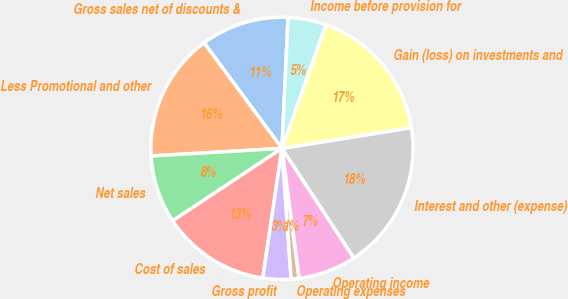Convert chart to OTSL. <chart><loc_0><loc_0><loc_500><loc_500><pie_chart><fcel>Gross sales net of discounts &<fcel>Less Promotional and other<fcel>Net sales<fcel>Cost of sales<fcel>Gross profit<fcel>Operating expenses<fcel>Operating income<fcel>Interest and other (expense)<fcel>Gain (loss) on investments and<fcel>Income before provision for<nl><fcel>10.86%<fcel>15.81%<fcel>8.39%<fcel>13.34%<fcel>3.45%<fcel>0.98%<fcel>7.16%<fcel>18.28%<fcel>17.04%<fcel>4.69%<nl></chart> 